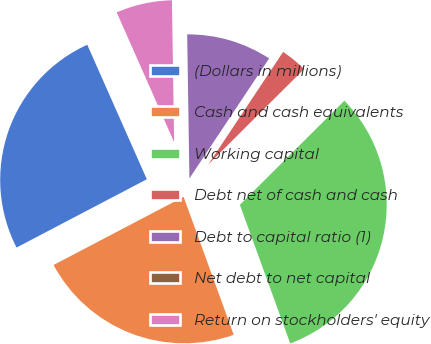Convert chart to OTSL. <chart><loc_0><loc_0><loc_500><loc_500><pie_chart><fcel>(Dollars in millions)<fcel>Cash and cash equivalents<fcel>Working capital<fcel>Debt net of cash and cash<fcel>Debt to capital ratio (1)<fcel>Net debt to net capital<fcel>Return on stockholders' equity<nl><fcel>26.05%<fcel>22.86%<fcel>31.93%<fcel>3.19%<fcel>9.58%<fcel>0.0%<fcel>6.39%<nl></chart> 